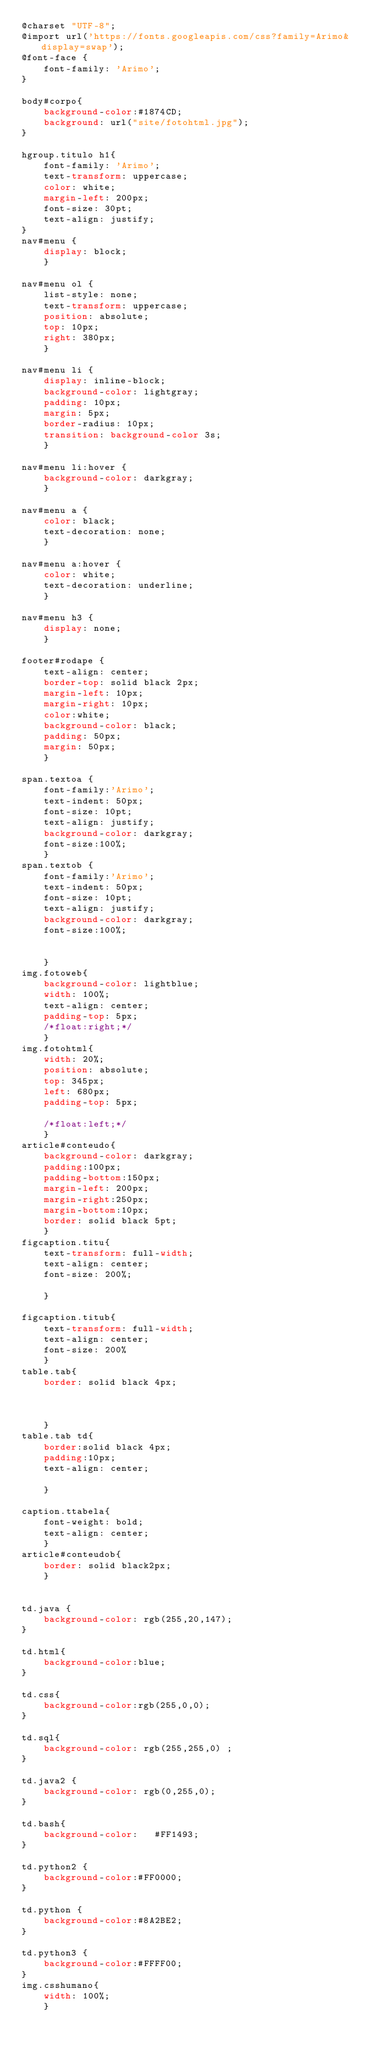<code> <loc_0><loc_0><loc_500><loc_500><_CSS_>@charset "UTF-8";
@import url('https://fonts.googleapis.com/css?family=Arimo&display=swap');
@font-face {
    font-family: 'Arimo';
}

body#corpo{
	background-color:#1874CD;
	background: url("site/fotohtml.jpg");
}

hgroup.titulo h1{
	font-family: 'Arimo';
	text-transform: uppercase;
	color: white;
	margin-left: 200px;
	font-size: 30pt;
	text-align: justify;
}
nav#menu {
	display: block;
	}

nav#menu ol {
	list-style: none;
	text-transform: uppercase;
	position: absolute;
	top: 10px;
	right: 380px;
	}

nav#menu li {
	display: inline-block;
	background-color: lightgray;
	padding: 10px;
	margin: 5px;
	border-radius: 10px;
	transition: background-color 3s;
	}

nav#menu li:hover {
	background-color: darkgray;
	}

nav#menu a {
	color: black;
	text-decoration: none;
	}

nav#menu a:hover {
	color: white;
	text-decoration: underline;
	}

nav#menu h3 {
	display: none;
	}
	
footer#rodape {
	text-align: center;
	border-top: solid black 2px;
	margin-left: 10px;
	margin-right: 10px;
	color:white;
	background-color: black;
	padding: 50px;
	margin: 50px;
	}
	
span.textoa {
	font-family:'Arimo';
	text-indent: 50px;
	font-size: 10pt;
	text-align: justify;
	background-color: darkgray;
	font-size:100%;
	}
span.textob {
	font-family:'Arimo';
	text-indent: 50px;
	font-size: 10pt;
	text-align: justify;
	background-color: darkgray;
	font-size:100%;
	
	
	}
img.fotoweb{
	background-color: lightblue;
	width: 100%;
	text-align: center;   
	padding-top: 5px;
	/*float:right;*/
	}
img.fotohtml{
	width: 20%;
	position: absolute;
	top: 345px;
	left: 680px;	
	padding-top: 5px;

	/*float:left;*/
	}
article#conteudo{
	background-color: darkgray;
	padding:100px;
	padding-bottom:150px;
	margin-left: 200px;
	margin-right:250px;
	margin-bottom:10px;
	border: solid black 5pt;
	}
figcaption.titu{
	text-transform: full-width;
	text-align: center;
	font-size: 200%;
	
	}
	
figcaption.titub{
	text-transform: full-width;
	text-align: center;
	font-size: 200%
	}
table.tab{
	border: solid black 4px; 
	
	
	
	}
table.tab td{
	border:solid black 4px;
	padding:10px;
	text-align: center;
	
	}

caption.ttabela{
	font-weight: bold;
	text-align: center;
	}
article#conteudob{
	border: solid black2px;
	}
	

td.java {
	background-color: rgb(255,20,147);
}

td.html{
	background-color:blue;
}

td.css{
	background-color:rgb(255,0,0);
}

td.sql{
	background-color: rgb(255,255,0) ;
}

td.java2 {
	background-color: rgb(0,255,0);
}

td.bash{
	background-color:	#FF1493;
}

td.python2 {
	background-color:#FF0000;
}

td.python {
	background-color:#8A2BE2;
}

td.python3 {
	background-color:#FFFF00;
}
img.csshumano{
	width: 100%;
	}</code> 